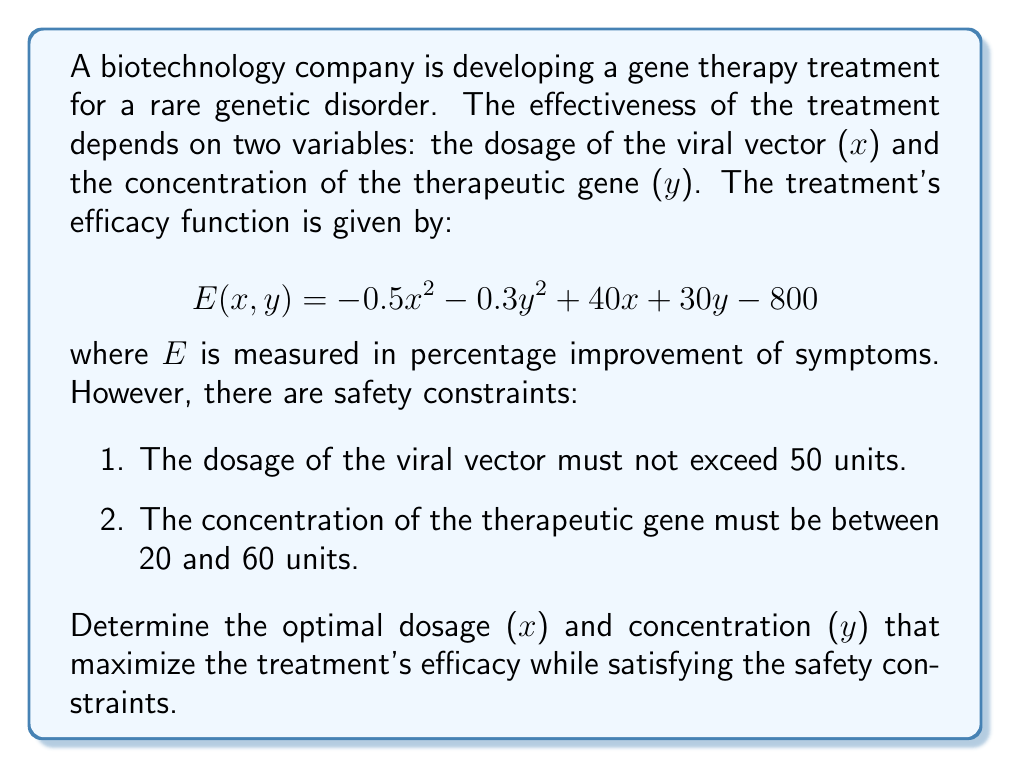Help me with this question. To solve this multivariable optimization problem with constraints, we'll follow these steps:

1. Find the critical points by taking partial derivatives and setting them to zero.
2. Check the boundaries of the constrained region.
3. Evaluate the efficacy function at all potential maximum points.

Step 1: Find critical points

The partial derivatives are:
$$\frac{\partial E}{\partial x} = -x + 40$$
$$\frac{\partial E}{\partial y} = -0.6y + 30$$

Setting these equal to zero:
$$-x + 40 = 0 \implies x = 40$$
$$-0.6y + 30 = 0 \implies y = 50$$

The critical point is (40, 50).

Step 2: Check boundaries

The constraints give us the following boundaries to check:
- x = 50 (maximum dosage)
- y = 20 (minimum concentration)
- y = 60 (maximum concentration)

Step 3: Evaluate the efficacy function

Let's evaluate E(x,y) at the critical point and the boundaries:

1. E(40, 50) = -0.5(40)^2 - 0.3(50)^2 + 40(40) + 30(50) - 800 = 1150

2. E(50, 20) = -0.5(50)^2 - 0.3(20)^2 + 40(50) + 30(20) - 800 = 1120

3. E(50, 60) = -0.5(50)^2 - 0.3(60)^2 + 40(50) + 30(60) - 800 = 1080

4. Along the line x = 50, we can find the maximum by solving:
   $$\frac{d}{dy}E(50,y) = -0.6y + 30 = 0 \implies y = 50$$
   This gives us the point (50, 50), which we've already evaluated in case 3.

The maximum value occurs at the critical point (40, 50), which satisfies all constraints.
Answer: The optimal dosage for the gene therapy treatment is 40 units of viral vector (x) and 50 units of therapeutic gene concentration (y), resulting in a maximum efficacy of 1150% improvement in symptoms. 